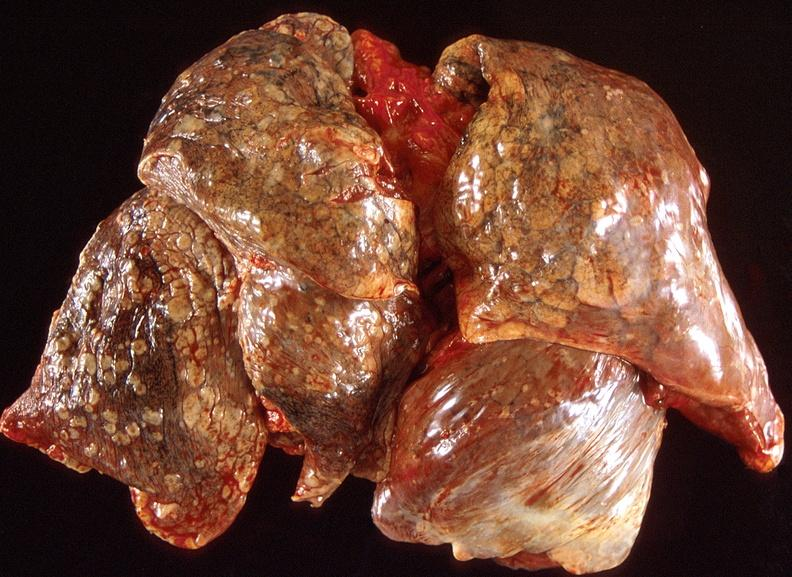what is present?
Answer the question using a single word or phrase. Respiratory 